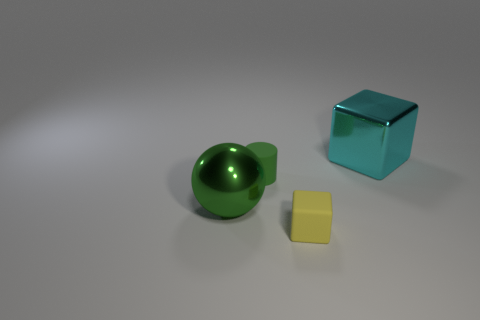Add 2 big red metal cylinders. How many objects exist? 6 Subtract all cyan blocks. How many blocks are left? 1 Subtract 1 cubes. How many cubes are left? 1 Subtract all balls. How many objects are left? 3 Subtract all yellow rubber objects. Subtract all large things. How many objects are left? 1 Add 2 large metallic spheres. How many large metallic spheres are left? 3 Add 3 big cyan shiny objects. How many big cyan shiny objects exist? 4 Subtract 0 purple balls. How many objects are left? 4 Subtract all purple balls. Subtract all red cylinders. How many balls are left? 1 Subtract all cyan cubes. How many red spheres are left? 0 